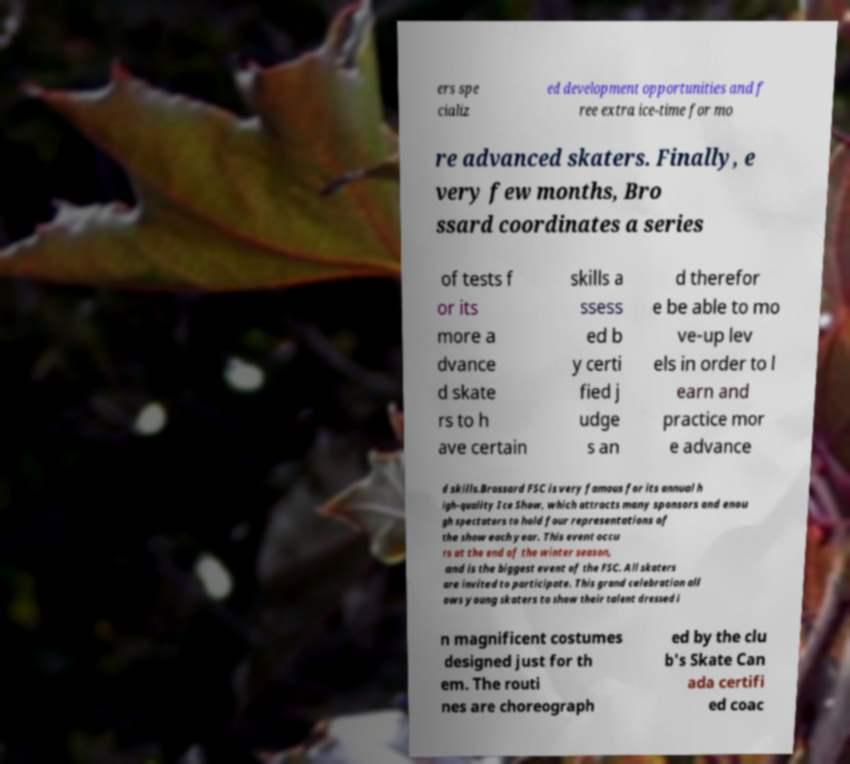Can you accurately transcribe the text from the provided image for me? ers spe cializ ed development opportunities and f ree extra ice-time for mo re advanced skaters. Finally, e very few months, Bro ssard coordinates a series of tests f or its more a dvance d skate rs to h ave certain skills a ssess ed b y certi fied j udge s an d therefor e be able to mo ve-up lev els in order to l earn and practice mor e advance d skills.Brossard FSC is very famous for its annual h igh-quality Ice Show, which attracts many sponsors and enou gh spectators to hold four representations of the show each year. This event occu rs at the end of the winter season, and is the biggest event of the FSC. All skaters are invited to participate. This grand celebration all ows young skaters to show their talent dressed i n magnificent costumes designed just for th em. The routi nes are choreograph ed by the clu b's Skate Can ada certifi ed coac 